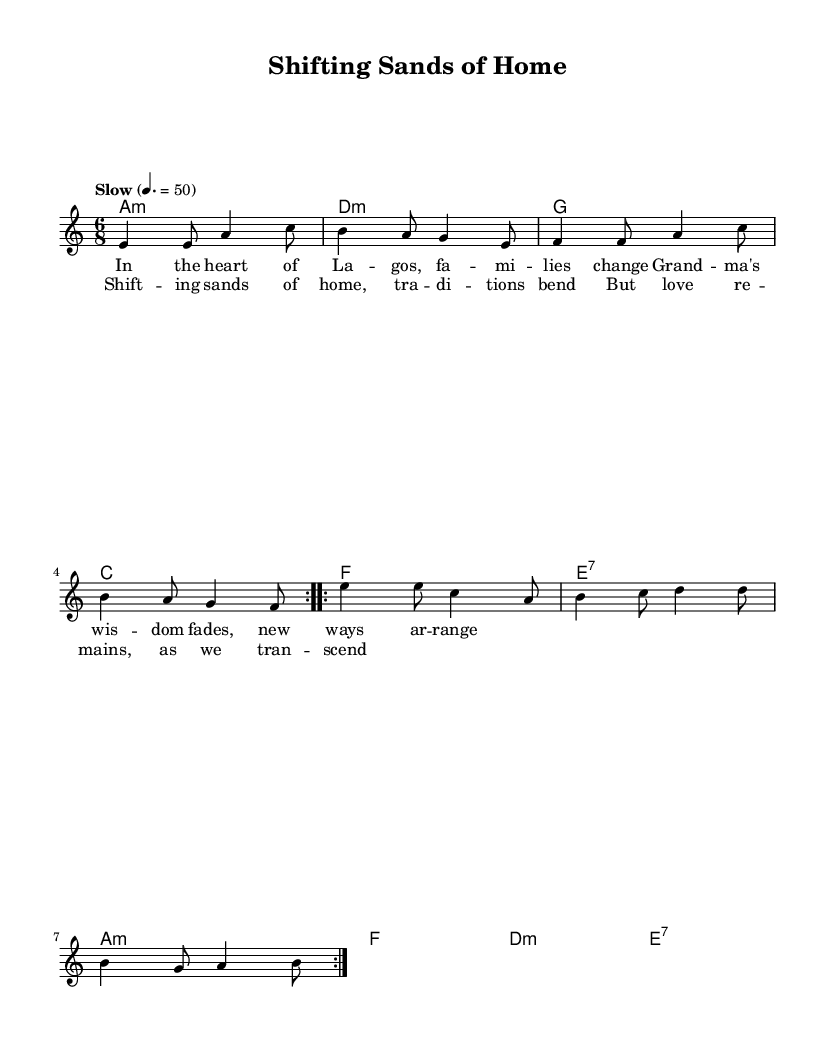What is the key signature of this music? The key signature is indicated at the beginning of the sheet music, showing one flat, which denotes A minor.
Answer: A minor What is the time signature of the piece? The time signature is displayed near the beginning of the sheet music, indicating that there are six beats in each measure, grouped into eighth notes.
Answer: 6/8 What tempo marking is given for the music? The tempo marking provides the speed of the piece, described as "Slow" with a metronome indication of 50 beats per minute.
Answer: Slow How many verses are present in the song? The sheet music contains one verse, as indicated by the repeated lyrics set to a single section of the melody.
Answer: One What is the first chord in the harmony section? The first chord is revealed in the harmony section and is labeled as A minor, denoting the chord played.
Answer: A minor What theme does the chorus express? The chorus contrasts traditional family structures with the enduring nature of love, reflecting on change and resilience in family dynamics.
Answer: Love remains How does this piece reflect the genre of Blues? The piece exhibits typical blues elements through its emotive lyrics, minor key selection, and a slow, soulful rhythm, characteristic of blues ballads.
Answer: Soulful rhythm 